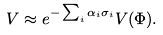Convert formula to latex. <formula><loc_0><loc_0><loc_500><loc_500>V \approx e ^ { - \sum _ { i } \alpha _ { i } \sigma _ { i } } V ( \Phi ) .</formula> 